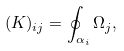<formula> <loc_0><loc_0><loc_500><loc_500>( K ) _ { i j } = \oint _ { \alpha _ { i } } \Omega _ { j } ,</formula> 